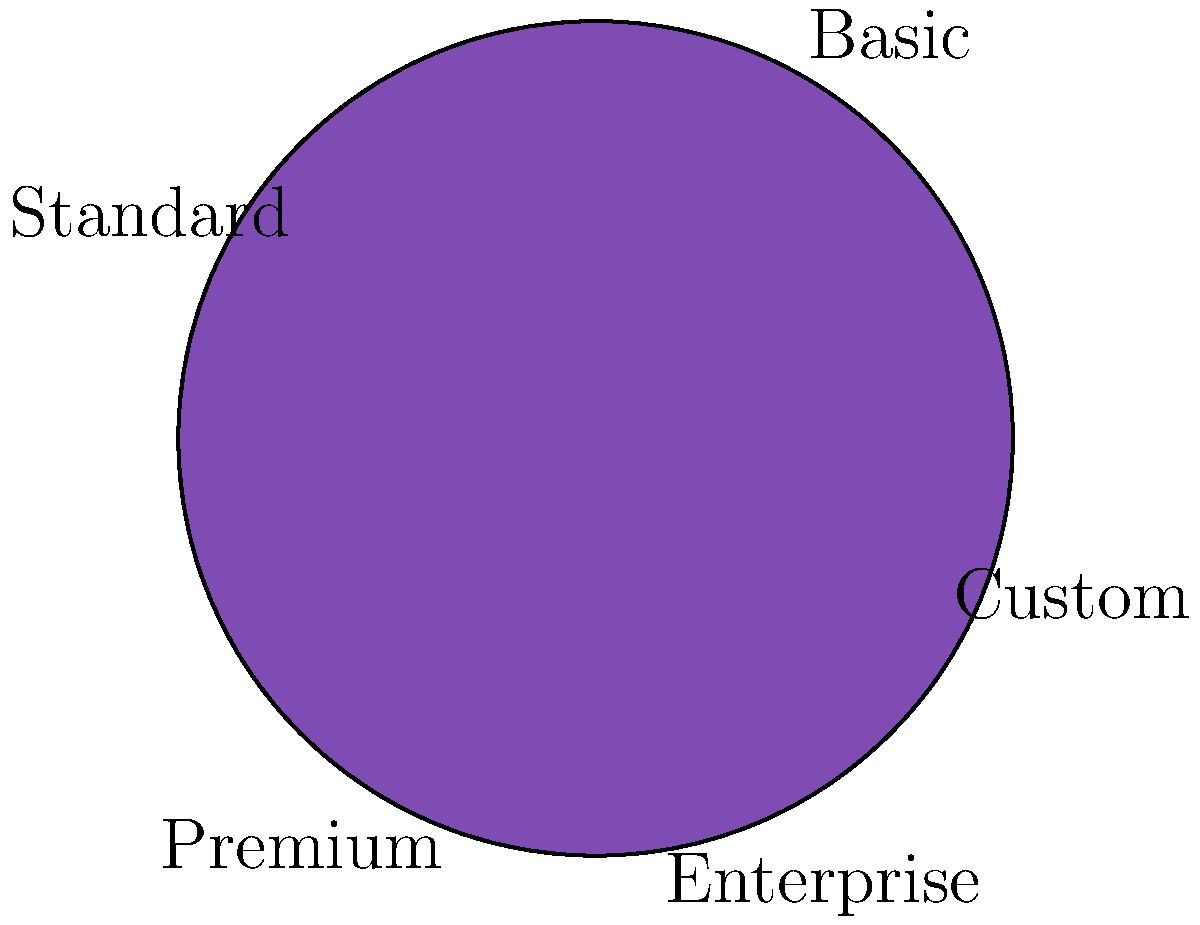As a small business owner considering affordable web design solutions, you're comparing different hosting plans. The pie chart shows the distribution of features across various hosting plans. If the "Basic" plan costs $10 per month and offers 30% of the total features, what would be the cost of the "Premium" plan that provides 20% of the features, assuming a linear relationship between cost and features? To solve this problem, we'll follow these steps:

1. Identify the given information:
   - Basic plan: 30% of features, $10 per month
   - Premium plan: 20% of features, cost unknown
   - Assume a linear relationship between cost and features

2. Calculate the cost per percentage of features for the Basic plan:
   Cost per % = $10 / 30% = $0.3333 per 1% of features

3. Calculate the cost for the Premium plan:
   Premium plan features = 20%
   Premium plan cost = 20 * $0.3333 = $6.67

4. Round the result to the nearest cent:
   $6.67 rounded to $6.67

Therefore, the cost of the Premium plan would be $6.67 per month.

This calculation assumes a perfectly linear relationship between cost and features, which may not always be the case in real-world scenarios. However, it provides a reasonable estimate for comparison purposes.
Answer: $6.67 per month 